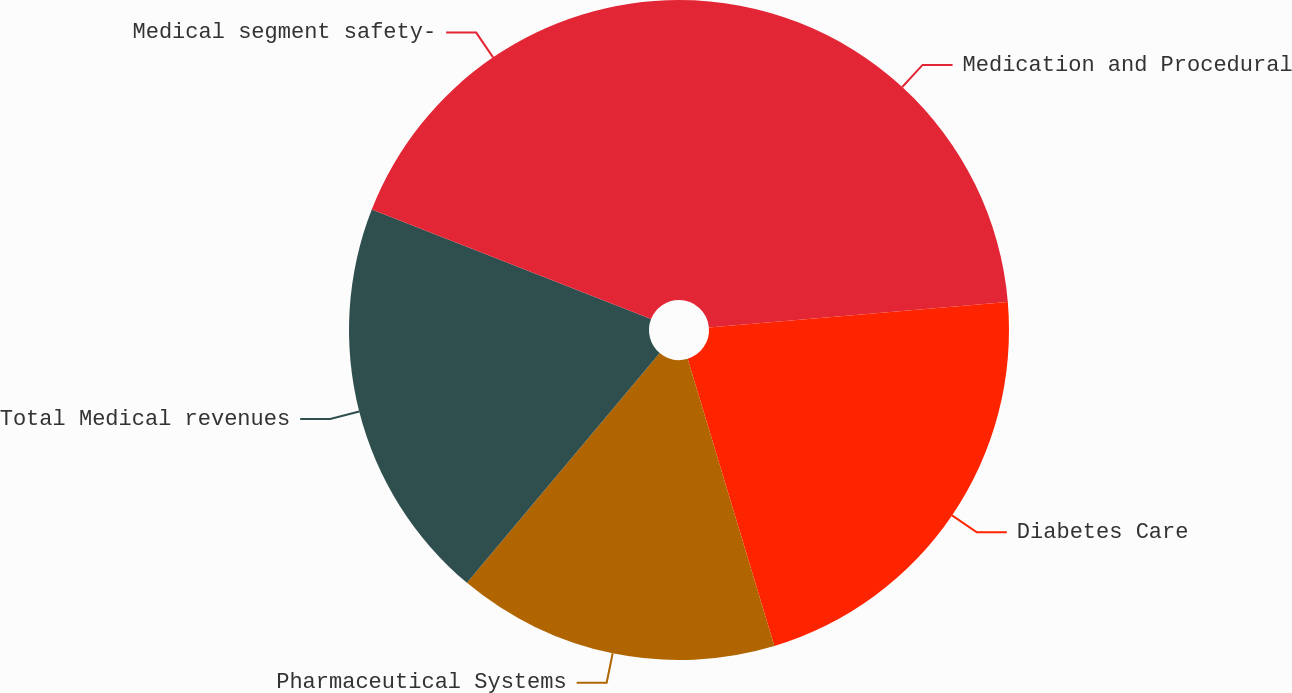Convert chart. <chart><loc_0><loc_0><loc_500><loc_500><pie_chart><fcel>Medication and Procedural<fcel>Diabetes Care<fcel>Pharmaceutical Systems<fcel>Total Medical revenues<fcel>Medical segment safety-<nl><fcel>23.65%<fcel>21.68%<fcel>15.77%<fcel>19.84%<fcel>19.05%<nl></chart> 